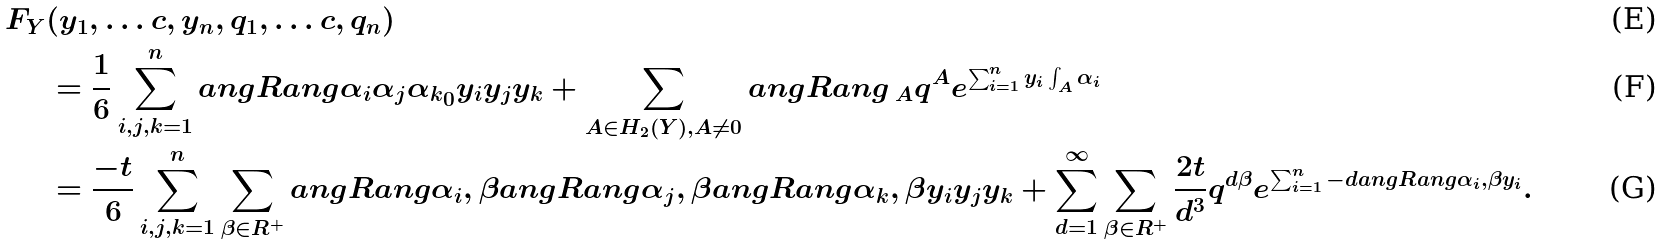Convert formula to latex. <formula><loc_0><loc_0><loc_500><loc_500>F _ { Y } & ( y _ { 1 } , \dots c , y _ { n } , q _ { 1 } , \dots c , q _ { n } ) \\ & = \frac { 1 } { 6 } \sum _ { i , j , k = 1 } ^ { n } \L a n g R a n g { \alpha _ { i } \alpha _ { j } \alpha _ { k } } _ { 0 } y _ { i } y _ { j } y _ { k } + \sum _ { A \in H _ { 2 } ( Y ) , A \neq 0 } \L a n g R a n g { \, } _ { A } q ^ { A } e ^ { \sum _ { i = 1 } ^ { n } y _ { i } \int _ { A } \alpha _ { i } } \\ & = \frac { - t } { 6 } \sum _ { i , j , k = 1 } ^ { n } \sum _ { \beta \in R ^ { + } } \L a n g R a n g { \alpha _ { i } , \beta } \L a n g R a n g { \alpha _ { j } , \beta } \L a n g R a n g { \alpha _ { k } , \beta } y _ { i } y _ { j } y _ { k } + \sum _ { d = 1 } ^ { \infty } \sum _ { \beta \in R ^ { + } } \frac { 2 t } { d ^ { 3 } } q ^ { d \beta } e ^ { \sum _ { i = 1 } ^ { n } - d \L a n g R a n g { \alpha _ { i } , \beta } y _ { i } } .</formula> 